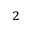<formula> <loc_0><loc_0><loc_500><loc_500>_ { 2 }</formula> 